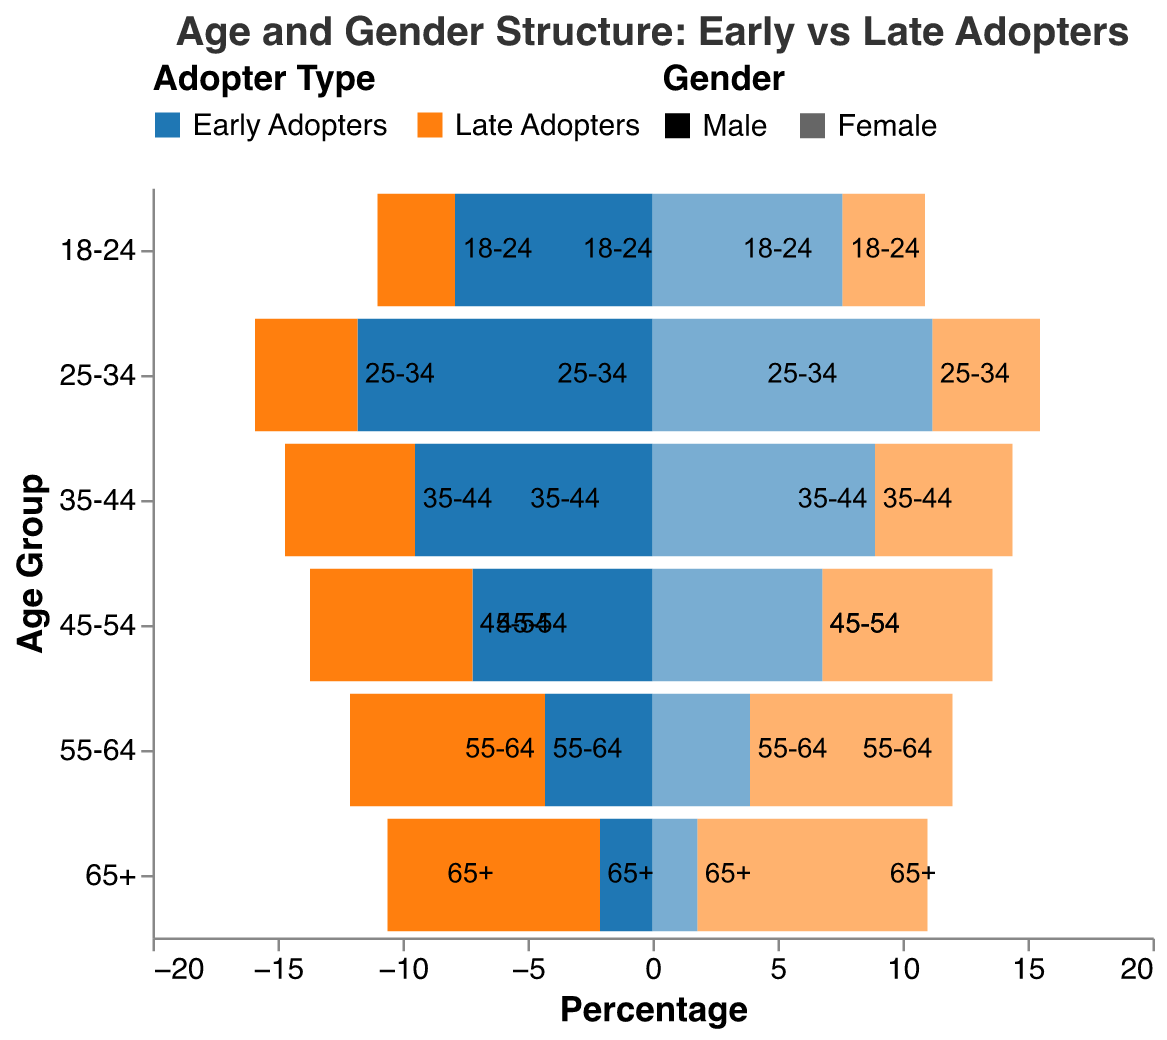What is the title of the figure? The title of the figure appears at the top and provides an overview of what the figure represents.
Answer: Age and Gender Structure: Early vs Late Adopters Which age group has the highest percentage of early adopters? By examining the bars for early adopters in the figure, the age group with the longest bar represents the highest percentage.
Answer: 25-34 How does the percentage of early adopter males compare to late adopter males in the 18-24 age group? Compare the lengths of the bars for early adopter males and late adopter males in the 18-24 age group. The early adopter males have a higher percentage.
Answer: Higher What is the total percentage of early adopters in the 65+ age group for both genders? Sum the percentages of early adopter males and females in the 65+ age group. 2.1 (males) + 1.8 (females) = 3.9
Answer: 3.9 Which gender has a higher percentage of late adopters in the 25-34 age group? Compare the lengths of the bars for late adopter males and late adopter females in the 25-34 age group. Late adopter females have a slightly higher percentage.
Answer: Female What is the percentage difference between early adopters and late adopters in the 55-64 age group for females? Subtract the percentage of early adopters from late adopters for females in the 55-64 age group. 8.1 - 3.9 = 4.2
Answer: 4.2 Which age group has the lowest percentage of late adopter females? Identify the age group with the shortest bar for late adopter females.
Answer: 18-24 Is there an age group where both early and late adopters have the same percentage for either gender? Analyze the bars for each age group and gender to find if any have the same length for both early and late adopters. Only females in the 45-54 age group have equal percentages.
Answer: Yes How does the distribution of early adopters in the 35-44 age group compare between males and females? Compare the lengths of the bars for early adopter males and females in the 35-44 age group. Males have a higher percentage than females.
Answer: Males are higher Overall, which type of adopters has more significant variations across different age groups? By observing the overall pattern and differences in bar lengths across age groups, it is evident which group shows more variation. Late adopters exhibit more variation across different age groups.
Answer: Late adopters 